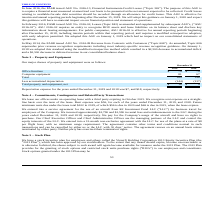According to Virnetx Holding's financial document, What is the depreciation expense for 2019? According to the financial document, $7. The relevant text states: "for the years ended December 31, 2019 and 2018 was $7, and $18, respectively...." Also, What is the amount spent on computer equipment in 2018? According to the financial document, 67. The relevant text states: "Computer equipment 81 67..." Also, What is the amount spent on office furniture in 2019? According to the financial document, $79. The relevant text states: "Office furniture $ 79 $ 79..." Also, can you calculate: What is the percentage change for depreciation expense in 2019? To answer this question, I need to perform calculations using the financial data. The calculation is: (7-18)/18 , which equals -61.11 (percentage). This is based on the information: "Office furniture $ 79 $ 79 reporting periods beginning after December 15, 2018, including interim periods within that reporting period, and requires a modified retrospective adop..." The key data points involved are: 18, 7. Also, can you calculate: What is the total amount spent on computer equipment in 2018 and 2019? Based on the calculation: 81 + 67 , the result is 148. This is based on the information: "Computer equipment 81 67 Computer equipment 81 67..." The key data points involved are: 67, 81. Additionally, Which year has a higher total sum of 'Depreciation expense' and 'Total property and equipment, net'? According to the financial document, 2018. The relevant text states: "2019 2018..." 